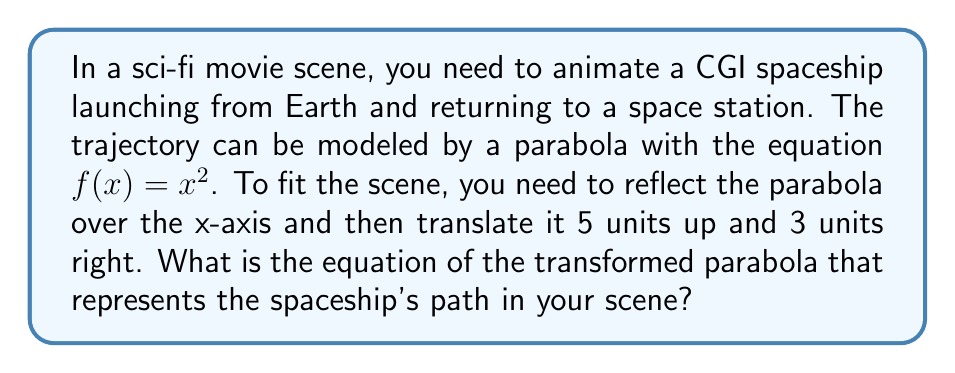Can you solve this math problem? Let's approach this step-by-step:

1) Start with the original function: $f(x)=x^2$

2) Reflect over the x-axis:
   This is done by negating the function: $-f(x) = -(x^2) = -x^2$

3) Translate 5 units up:
   Add 5 to the function: $-x^2 + 5$

4) Translate 3 units right:
   Replace every x with (x-3): $-(x-3)^2 + 5$

5) Expand the squared term:
   $-(x^2-6x+9) + 5$

6) Distribute the negative sign:
   $-x^2+6x-9 + 5$

7) Simplify:
   $-x^2+6x-4$

Therefore, the final equation of the transformed parabola is $g(x) = -x^2+6x-4$.
Answer: $g(x) = -x^2+6x-4$ 